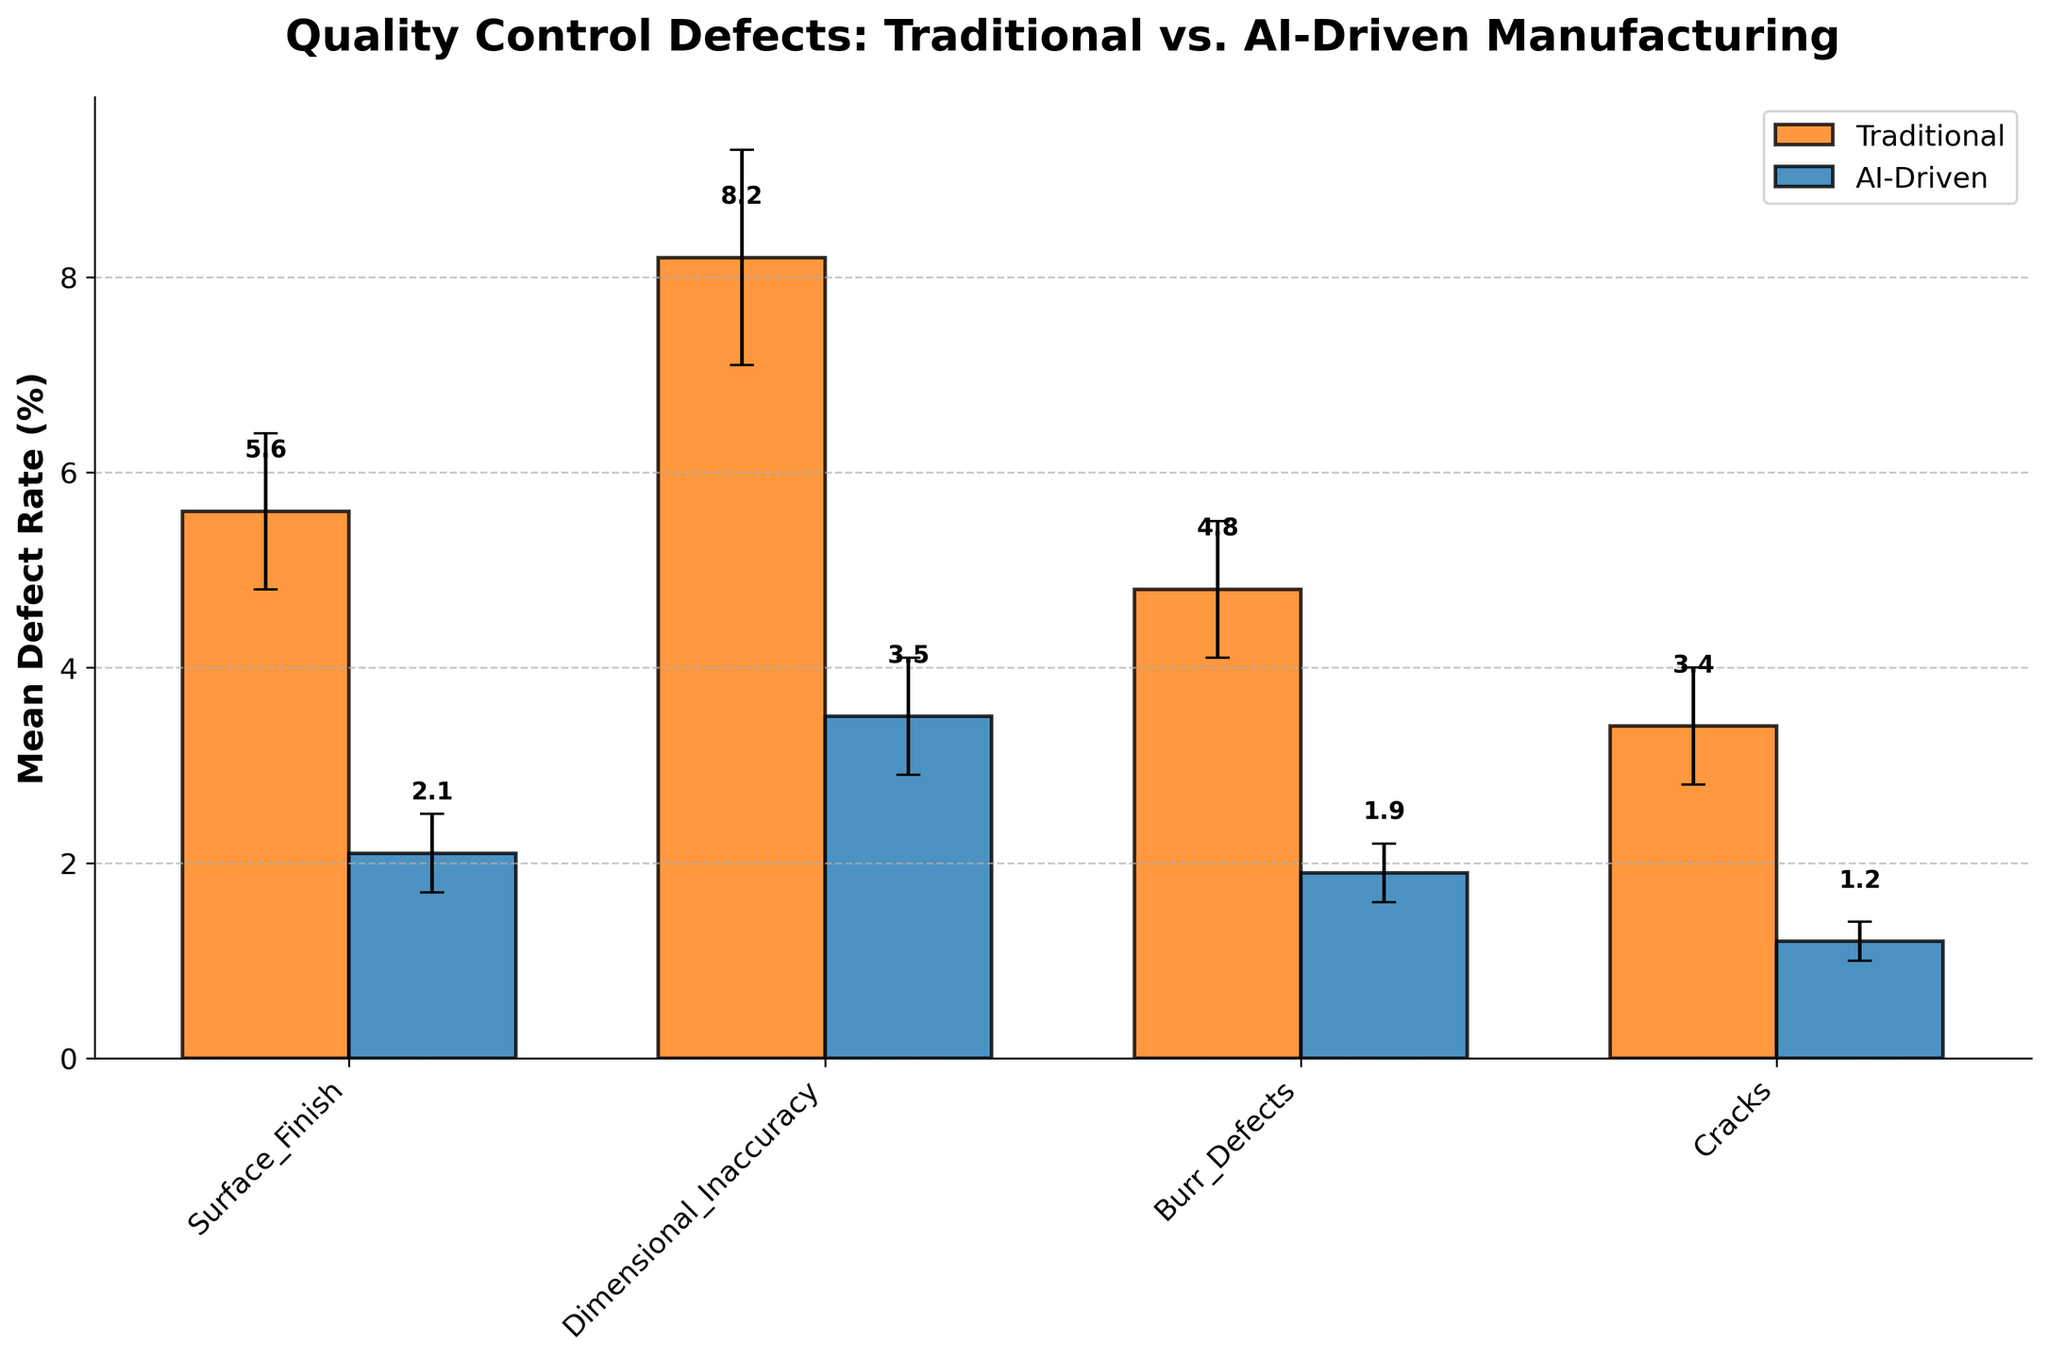What is the title of the figure? The title of the figure is usually located at the top center. By reading it, we find the title "Quality Control Defects: Traditional vs. AI-Driven Manufacturing."
Answer: Quality Control Defects: Traditional vs. AI-Driven Manufacturing Which manufacturing system has a higher mean defect rate for Surface Finish? Look at the error bars for Surface Finish and compare the heights of the bars. The bar for Traditional is higher than that for AI-Driven.
Answer: Traditional What is the mean defect rate for Cracks in AI-Driven manufacturing? Locate the bar for Cracks under the AI-Driven series. The bar has a label indicating 1.2%.
Answer: 1.2% What is the range of mean defect rate for Dimensional Inaccuracy in traditional manufacturing considering the error bar? Find the bar for Dimensional Inaccuracy under the Traditional series. The mean defect rate is 8.2% and the error bar indicates 1.1%. Therefore, the range is 8.2% ± 1.1%, which is 7.1% to 9.3%.
Answer: 7.1% to 9.3% Which defect type exhibits the smallest mean defect rate in AI-Driven manufacturing? Compare all bars within the AI-Driven system. The bar for Cracks is the smallest.
Answer: Cracks What is the difference in mean defect rates for Burr Defects between Traditional and AI-Driven systems? Find the bars for Burr Defects in both systems. The Traditional rate is 4.8% and the AI-Driven rate is 1.9%. The difference is 4.8% - 1.9% = 2.9%.
Answer: 2.9% For which defect type is the standard deviation the highest in Traditional manufacturing? Examine the error bars in the Traditional series. Dimensional Inaccuracy has the largest error bar of 1.1%.
Answer: Dimensional Inaccuracy What defect type has the highest mean defect rate in AI-Driven manufacturing? Compare the bars under the AI-Driven system. Dimensional Inaccuracy has the highest bar, indicating a rate of 3.5%.
Answer: Dimensional Inaccuracy Which manufacturing system shows a lower mean defect rate in all defect types? Compare all categories between the two systems. AI-Driven consistently has lower bars in all defect types.
Answer: AI-Driven What is the combined mean defect rate for Burr Defects and Cracks in Traditional manufacturing? Add the mean defect rates for the two types. Burr Defects: 4.8%, Cracks: 3.4%. Combined rate: 4.8% + 3.4% = 8.2%.
Answer: 8.2% 